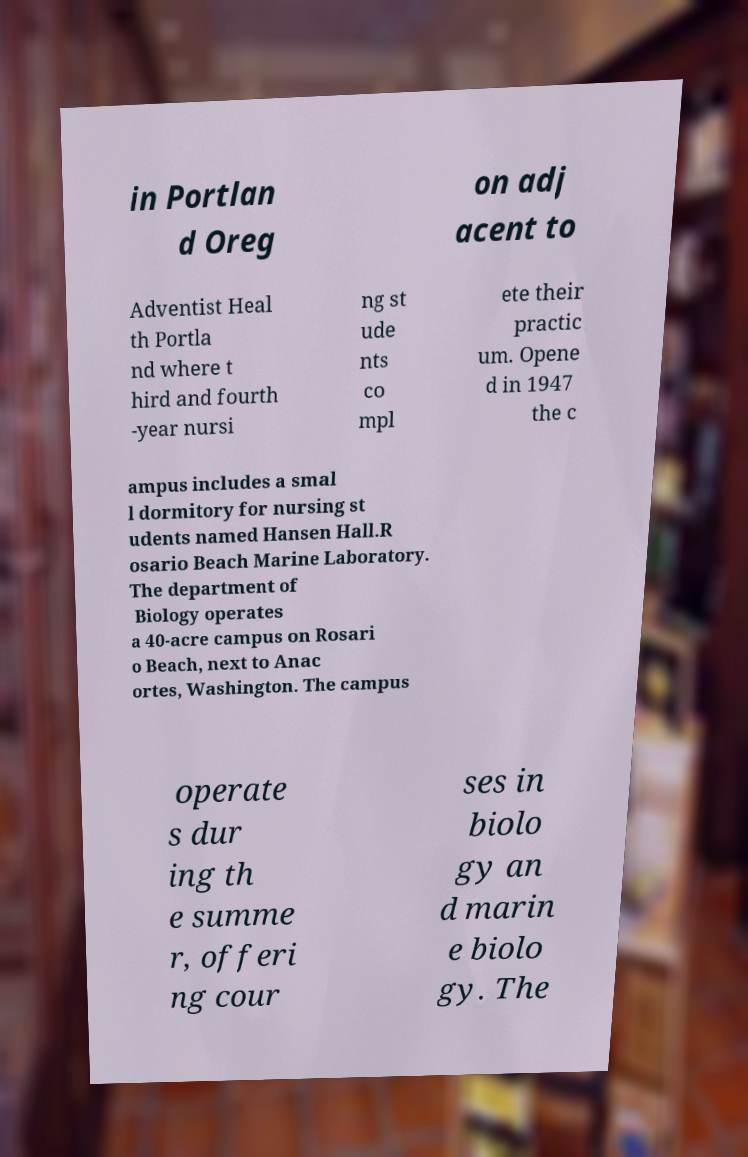What messages or text are displayed in this image? I need them in a readable, typed format. in Portlan d Oreg on adj acent to Adventist Heal th Portla nd where t hird and fourth -year nursi ng st ude nts co mpl ete their practic um. Opene d in 1947 the c ampus includes a smal l dormitory for nursing st udents named Hansen Hall.R osario Beach Marine Laboratory. The department of Biology operates a 40-acre campus on Rosari o Beach, next to Anac ortes, Washington. The campus operate s dur ing th e summe r, offeri ng cour ses in biolo gy an d marin e biolo gy. The 